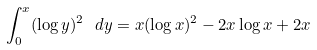Convert formula to latex. <formula><loc_0><loc_0><loc_500><loc_500>\int _ { 0 } ^ { x } ( \log y ) ^ { 2 } \ d y = x ( \log x ) ^ { 2 } - 2 x \log x + 2 x</formula> 